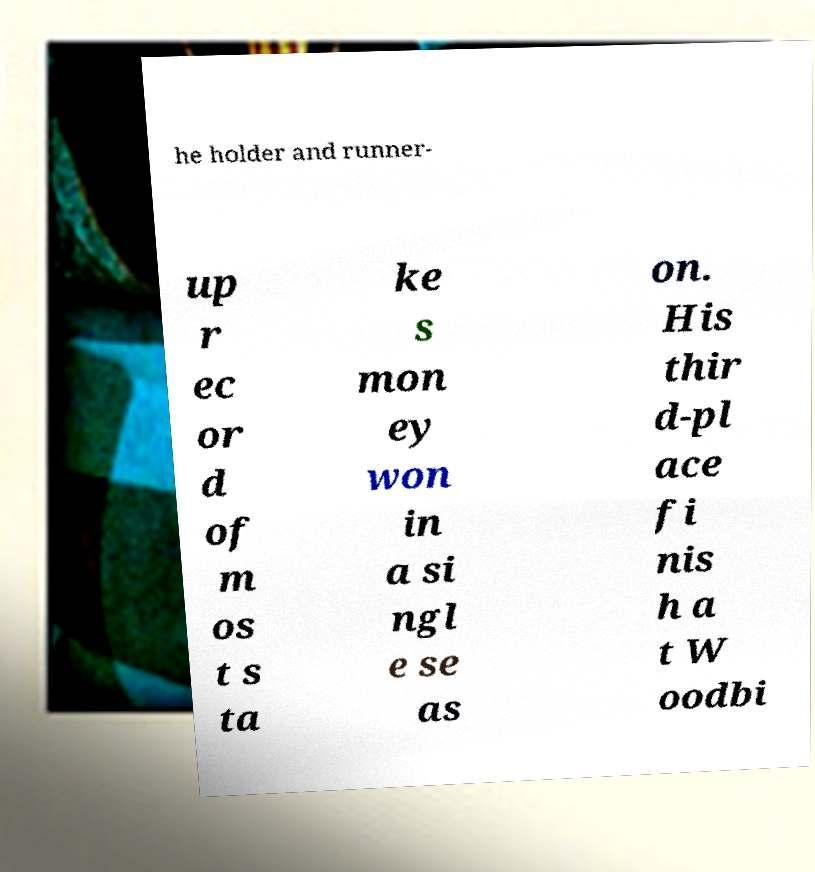Can you read and provide the text displayed in the image?This photo seems to have some interesting text. Can you extract and type it out for me? he holder and runner- up r ec or d of m os t s ta ke s mon ey won in a si ngl e se as on. His thir d-pl ace fi nis h a t W oodbi 